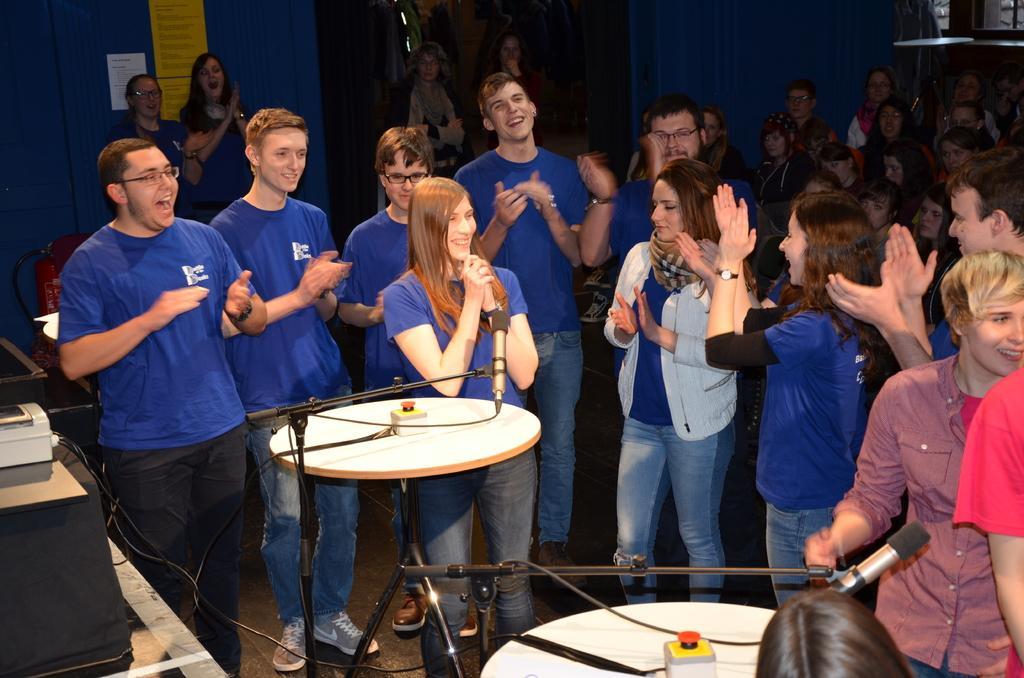Describe this image in one or two sentences. In this image, we can see tables, mic stands and some objects and cables and boxes. In the background, there are people and are clapping hands and some of them are wearing glasses and we can see some posters on the wall and there are curtains. 